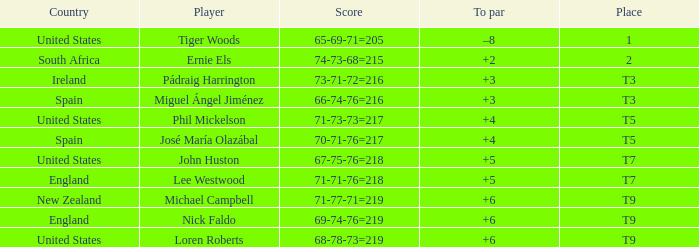What is Score, when Country is "United States", and when To Par is "+4"? 71-73-73=217. 